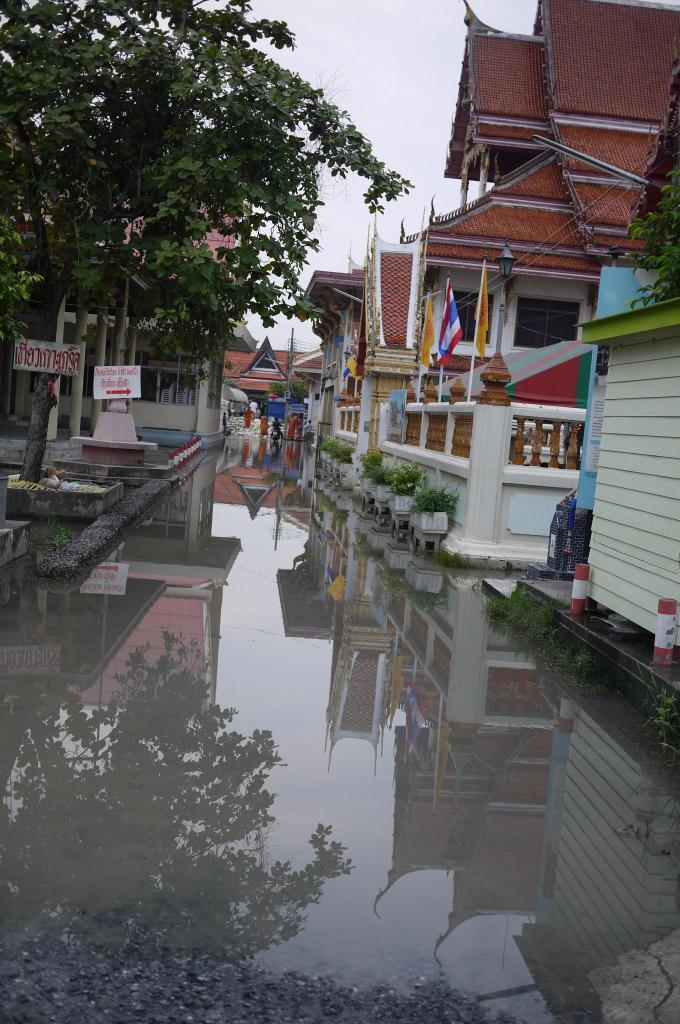What is the main feature of the road in the image? There is a lot of water on the road in the image. What type of structures can be seen beside the road? There are houses beside the road in the image. What is located on the left side of the image? There are trees on the left side of the image. What is attached to the trees in the image? Boards are attached to the trees in the image. What type of insurance is required for the fifth tree in the image? There is no mention of insurance or a fifth tree in the image. 